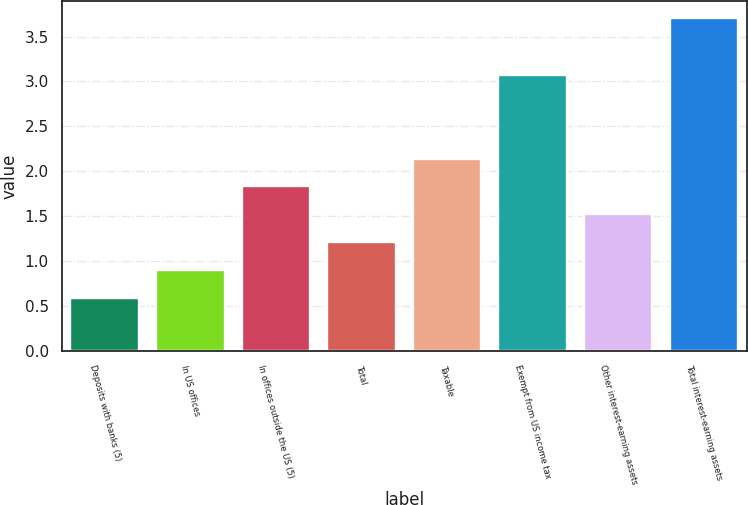Convert chart to OTSL. <chart><loc_0><loc_0><loc_500><loc_500><bar_chart><fcel>Deposits with banks (5)<fcel>In US offices<fcel>In offices outside the US (5)<fcel>Total<fcel>Taxable<fcel>Exempt from US income tax<fcel>Other interest-earning assets<fcel>Total interest-earning assets<nl><fcel>0.59<fcel>0.9<fcel>1.83<fcel>1.21<fcel>2.14<fcel>3.07<fcel>1.52<fcel>3.71<nl></chart> 